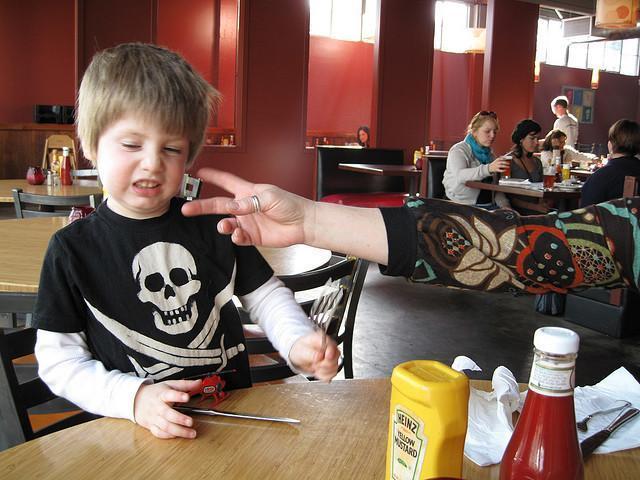How many bottles are there?
Give a very brief answer. 2. How many people are in the photo?
Give a very brief answer. 5. How many chairs are in the photo?
Give a very brief answer. 2. How many birds are standing in the pizza box?
Give a very brief answer. 0. 